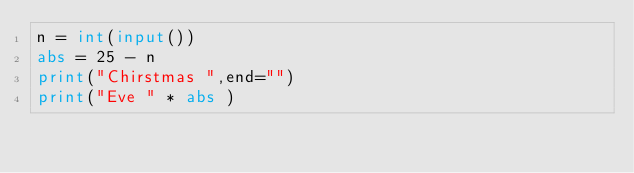<code> <loc_0><loc_0><loc_500><loc_500><_Python_>n = int(input())
abs = 25 - n
print("Chirstmas ",end="")
print("Eve " * abs )
</code> 